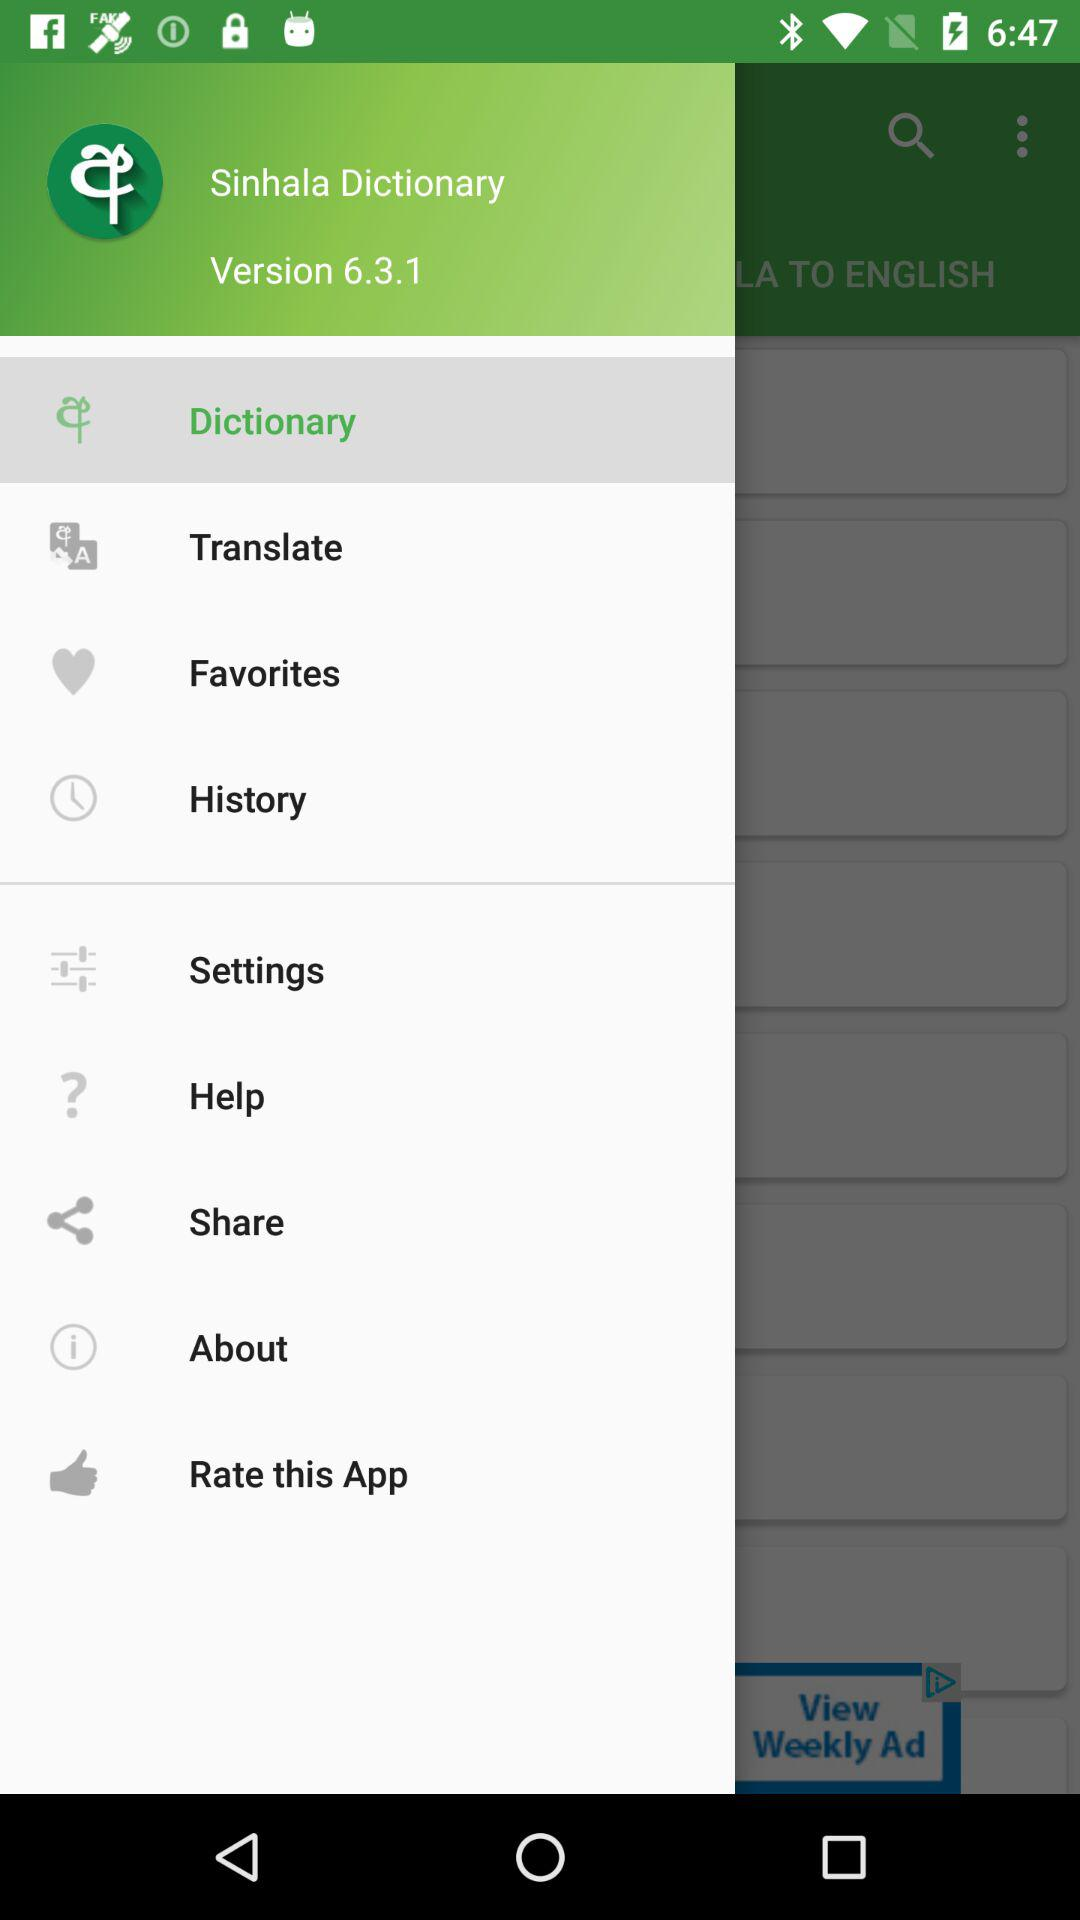Which option has been selected? The tab that has been selected is "Dictionary". 